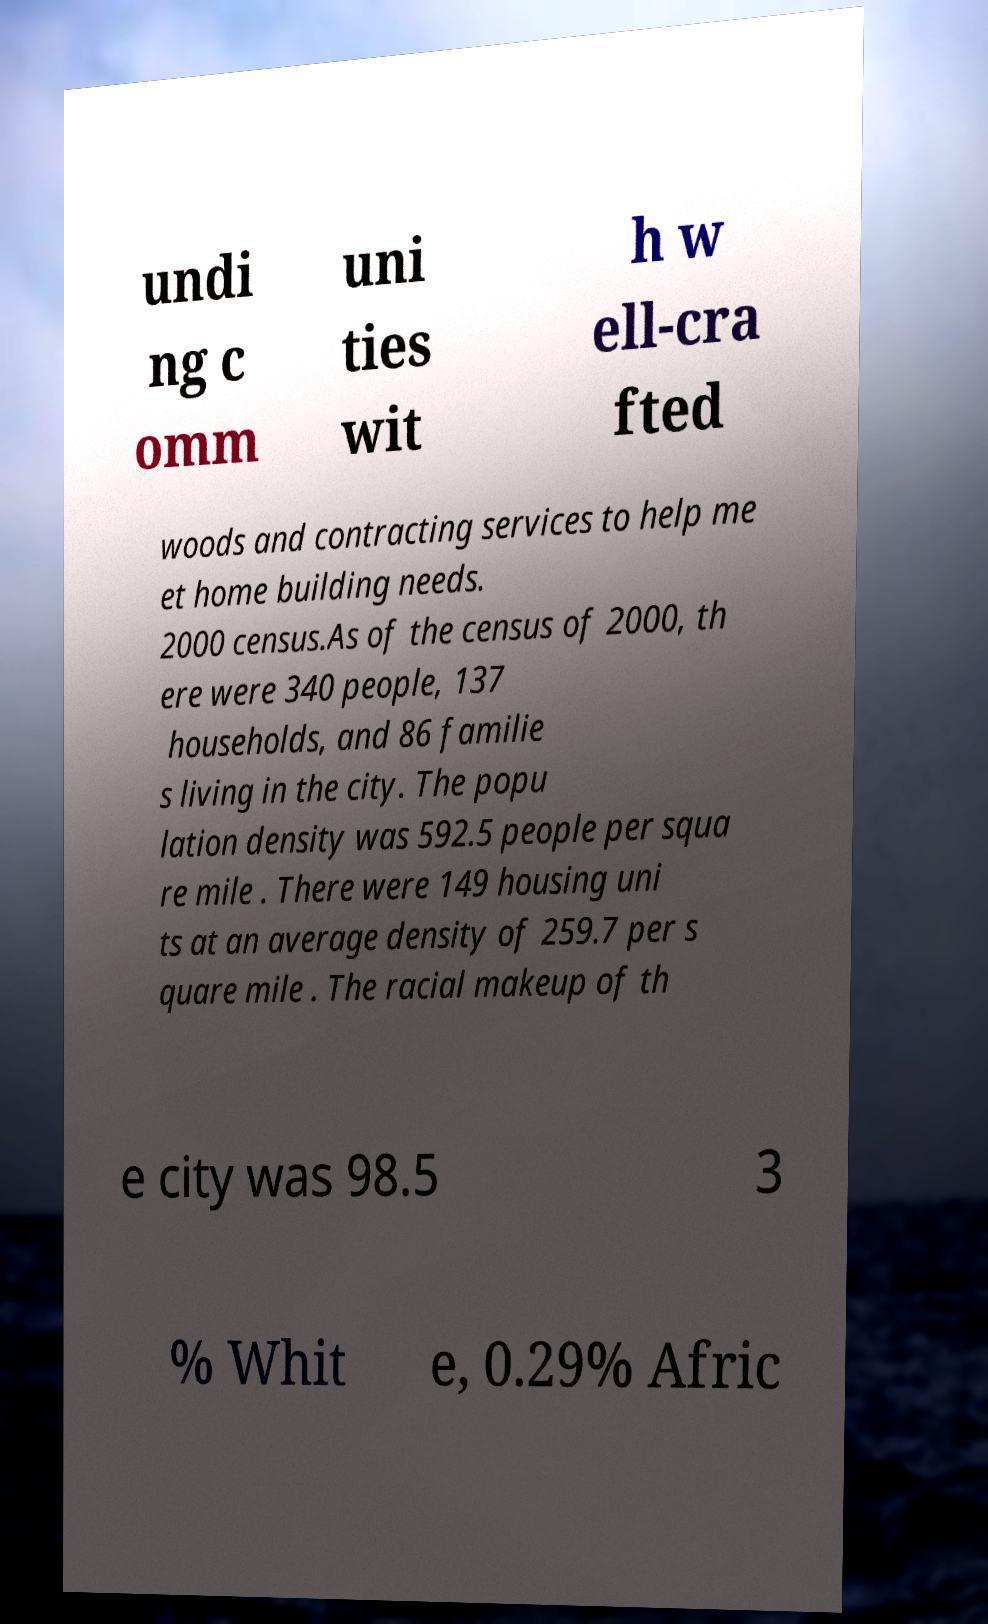Please identify and transcribe the text found in this image. undi ng c omm uni ties wit h w ell-cra fted woods and contracting services to help me et home building needs. 2000 census.As of the census of 2000, th ere were 340 people, 137 households, and 86 familie s living in the city. The popu lation density was 592.5 people per squa re mile . There were 149 housing uni ts at an average density of 259.7 per s quare mile . The racial makeup of th e city was 98.5 3 % Whit e, 0.29% Afric 